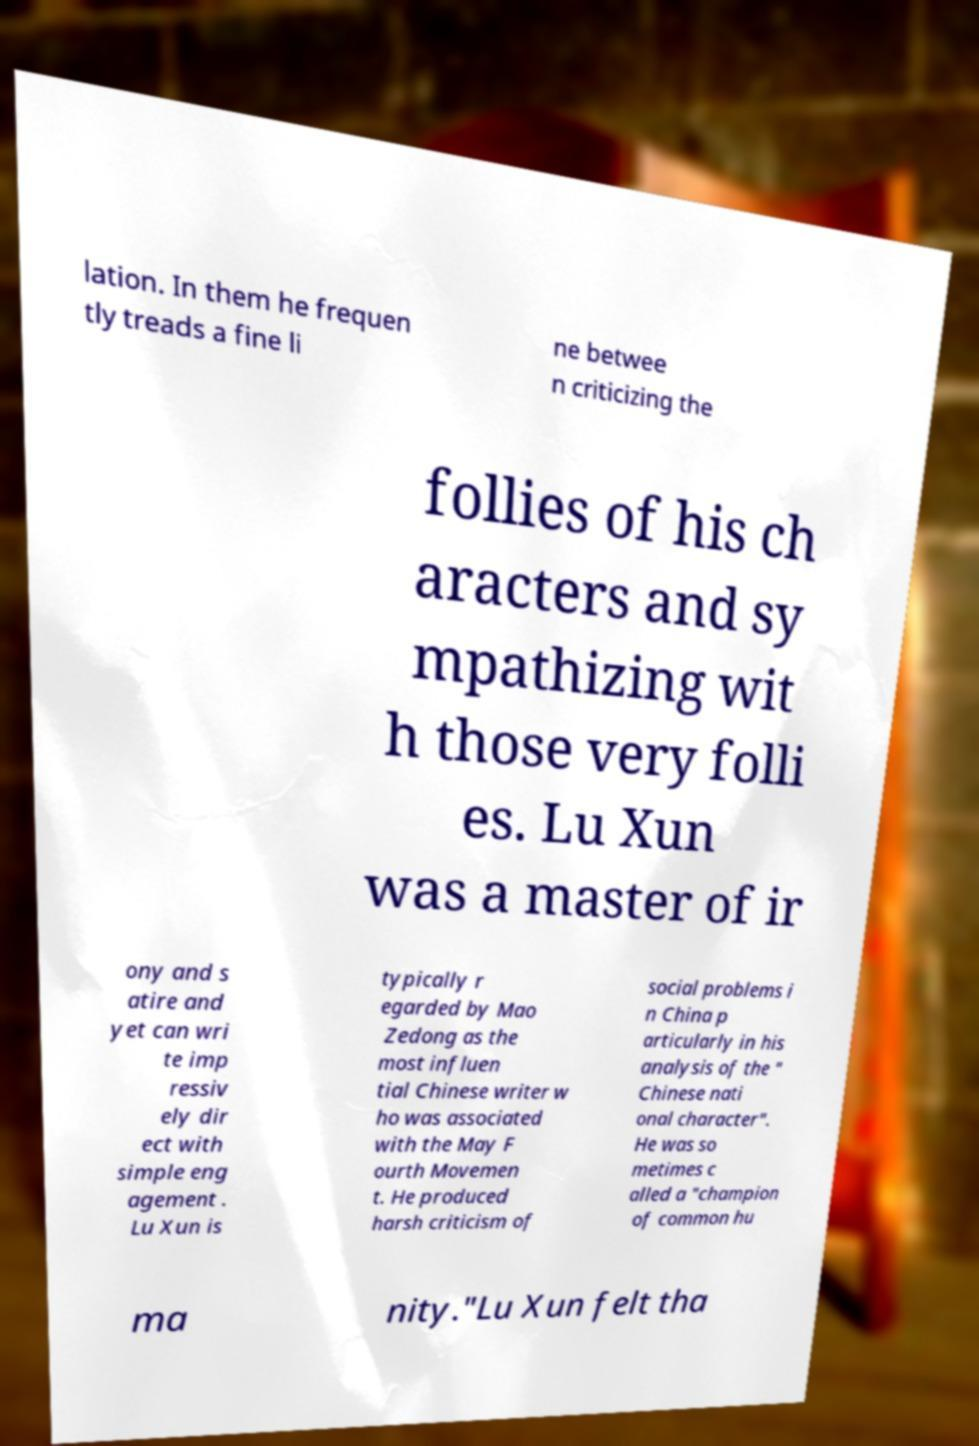Please read and relay the text visible in this image. What does it say? lation. In them he frequen tly treads a fine li ne betwee n criticizing the follies of his ch aracters and sy mpathizing wit h those very folli es. Lu Xun was a master of ir ony and s atire and yet can wri te imp ressiv ely dir ect with simple eng agement . Lu Xun is typically r egarded by Mao Zedong as the most influen tial Chinese writer w ho was associated with the May F ourth Movemen t. He produced harsh criticism of social problems i n China p articularly in his analysis of the " Chinese nati onal character". He was so metimes c alled a "champion of common hu ma nity."Lu Xun felt tha 